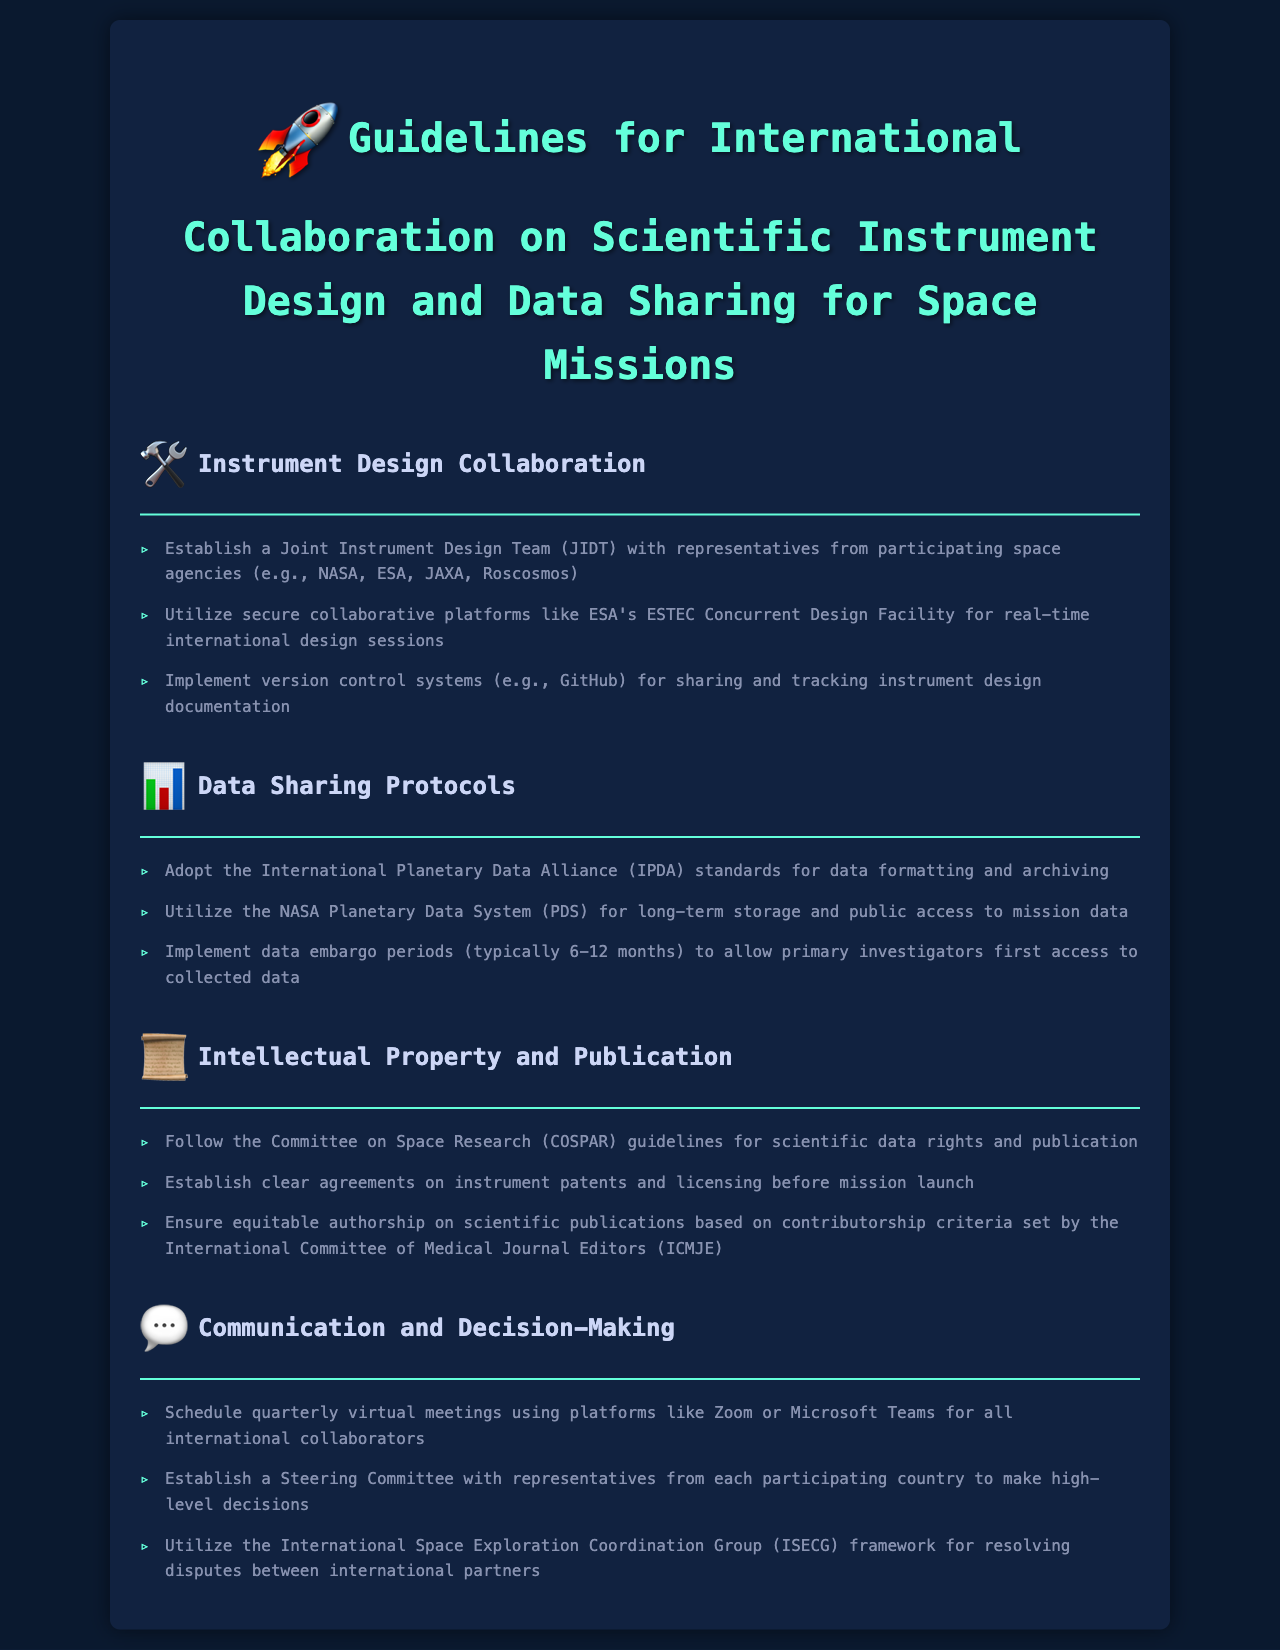What is the title of the document? The title of the document, which is the header, states the main focus of the guidelines.
Answer: Guidelines for International Collaboration on Scientific Instrument Design and Data Sharing for Space Missions What organization’s standards should be adopted for data formatting? The document specifies the organization that provides standards for data formatting in the data sharing protocols section.
Answer: International Planetary Data Alliance How long are the typical data embargo periods? The document mentions the duration for which embargoes are typically observed in relation to data access.
Answer: 6-12 months What type of committee is established for decision-making? The document outlines the type of committee that is set up to make high-level decisions among international partners.
Answer: Steering Committee Which agencies should be represented in the Joint Instrument Design Team? The document lists the agencies that are suggested to have representatives in the collaborative team for instrument design.
Answer: NASA, ESA, JAXA, Roscosmos What platform is recommended for secure collaborative design sessions? The document provides a specific platform that is recommended for conducting real-time design sessions among collaborators.
Answer: ESA's ESTEC Concurrent Design Facility What is expected from authorship on scientific publications? The document specifies the criteria that should be adhered to for authorship recognition based on contributions to the research.
Answer: Equitable authorship What communication platforms are suggested for virtual meetings? The document recommends specific platforms to use for conducting virtual meetings among the international collaborators.
Answer: Zoom or Microsoft Teams 